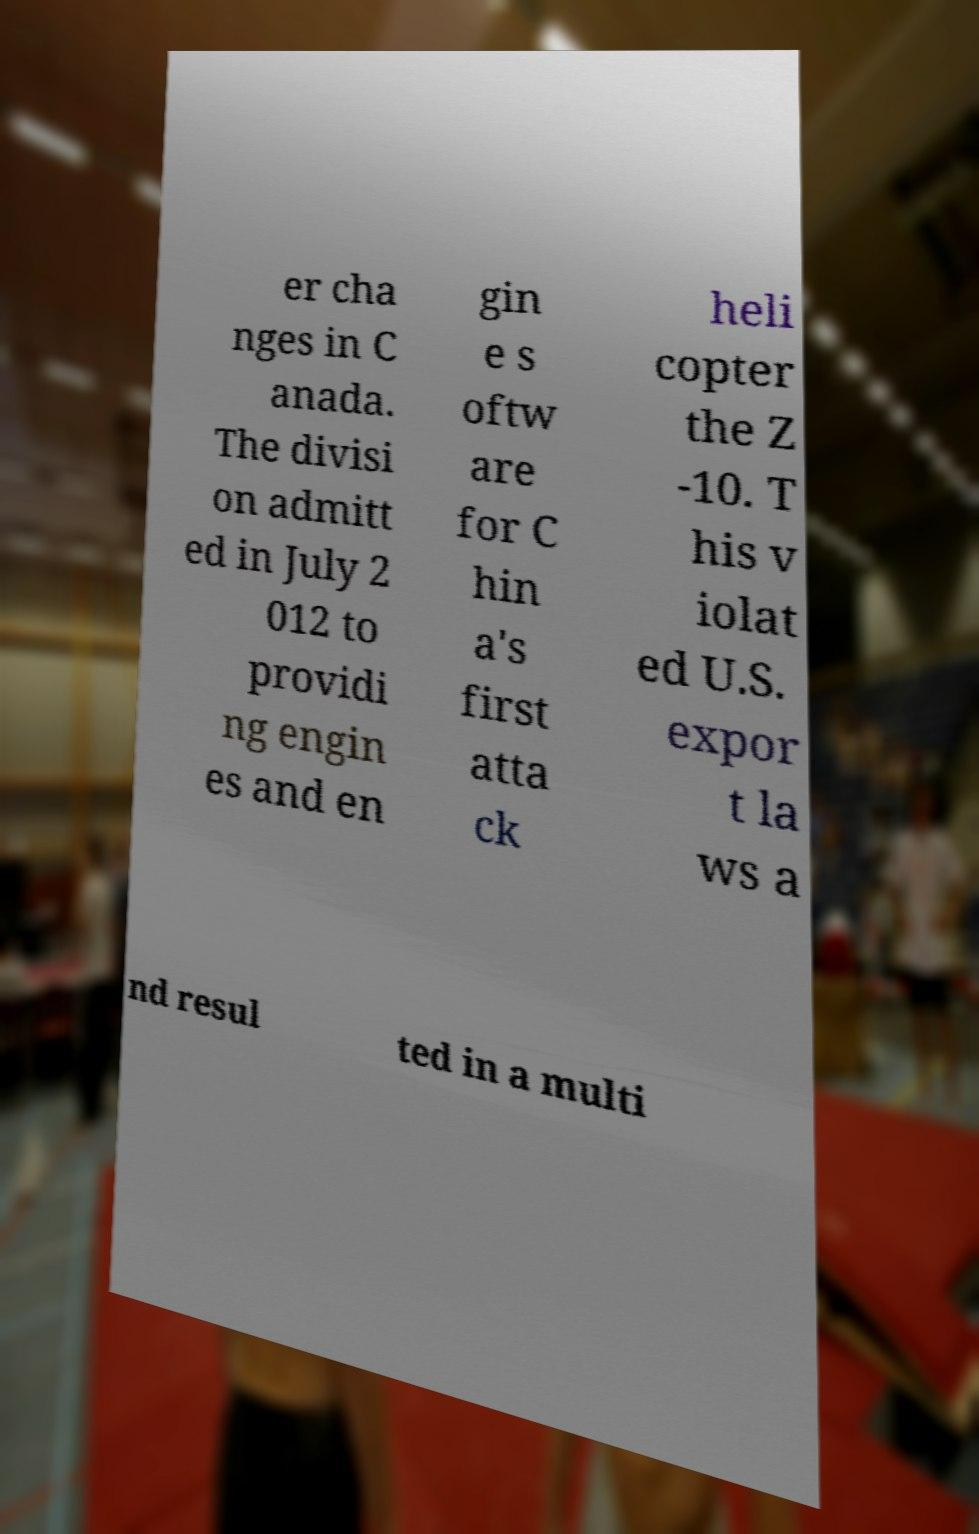Please read and relay the text visible in this image. What does it say? er cha nges in C anada. The divisi on admitt ed in July 2 012 to providi ng engin es and en gin e s oftw are for C hin a's first atta ck heli copter the Z -10. T his v iolat ed U.S. expor t la ws a nd resul ted in a multi 